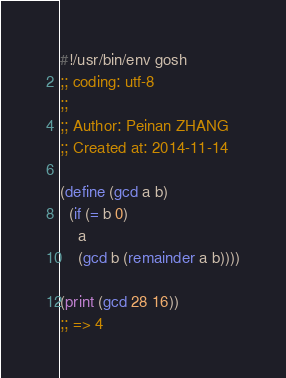Convert code to text. <code><loc_0><loc_0><loc_500><loc_500><_Scheme_>#!/usr/bin/env gosh
;; coding: utf-8
;; 
;; Author: Peinan ZHANG
;; Created at: 2014-11-14

(define (gcd a b)
  (if (= b 0)
    a
    (gcd b (remainder a b))))

(print (gcd 28 16))
;; => 4
</code> 